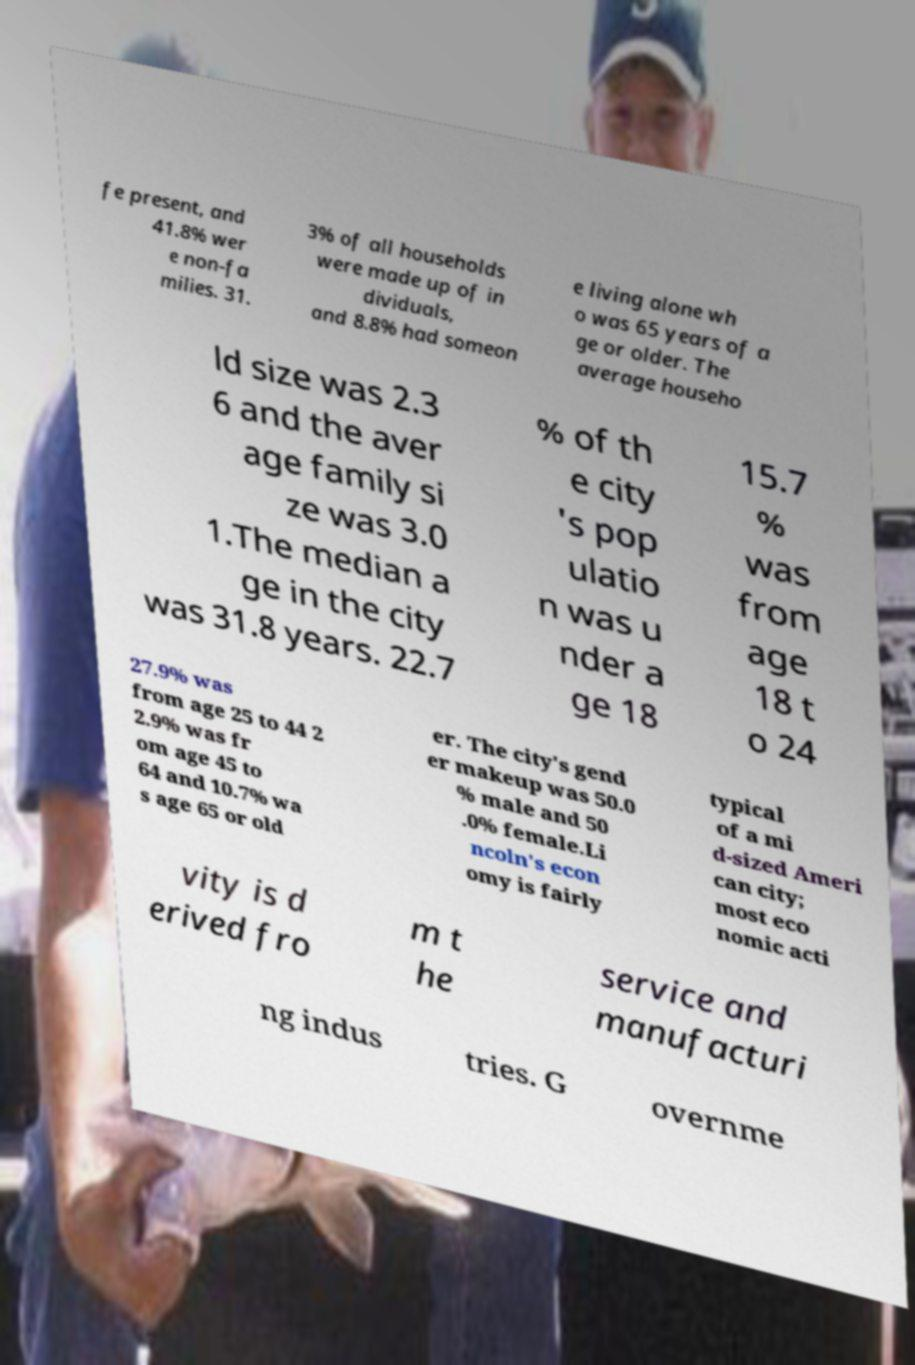Please read and relay the text visible in this image. What does it say? fe present, and 41.8% wer e non-fa milies. 31. 3% of all households were made up of in dividuals, and 8.8% had someon e living alone wh o was 65 years of a ge or older. The average househo ld size was 2.3 6 and the aver age family si ze was 3.0 1.The median a ge in the city was 31.8 years. 22.7 % of th e city 's pop ulatio n was u nder a ge 18 15.7 % was from age 18 t o 24 27.9% was from age 25 to 44 2 2.9% was fr om age 45 to 64 and 10.7% wa s age 65 or old er. The city's gend er makeup was 50.0 % male and 50 .0% female.Li ncoln's econ omy is fairly typical of a mi d-sized Ameri can city; most eco nomic acti vity is d erived fro m t he service and manufacturi ng indus tries. G overnme 